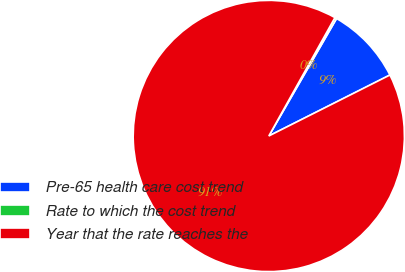<chart> <loc_0><loc_0><loc_500><loc_500><pie_chart><fcel>Pre-65 health care cost trend<fcel>Rate to which the cost trend<fcel>Year that the rate reaches the<nl><fcel>9.25%<fcel>0.22%<fcel>90.52%<nl></chart> 